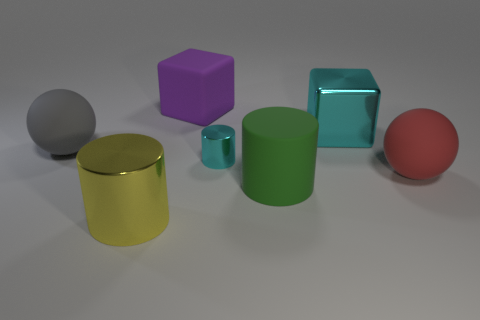How many other objects are there of the same color as the big shiny block?
Offer a very short reply. 1. The rubber thing to the left of the big shiny cylinder has what shape?
Ensure brevity in your answer.  Sphere. What number of objects are yellow metal objects or big red rubber cylinders?
Provide a short and direct response. 1. There is a red matte ball; is it the same size as the cyan shiny thing in front of the big gray matte sphere?
Make the answer very short. No. How many other objects are the same material as the small cyan object?
Ensure brevity in your answer.  2. What number of objects are metal things left of the big purple matte object or large things that are right of the large purple matte thing?
Make the answer very short. 4. There is a large gray thing that is the same shape as the red rubber object; what is it made of?
Offer a very short reply. Rubber. Is there a tiny gray matte thing?
Your response must be concise. No. What size is the object that is both behind the tiny metallic cylinder and on the right side of the large matte cylinder?
Make the answer very short. Large. What is the shape of the big yellow object?
Give a very brief answer. Cylinder. 